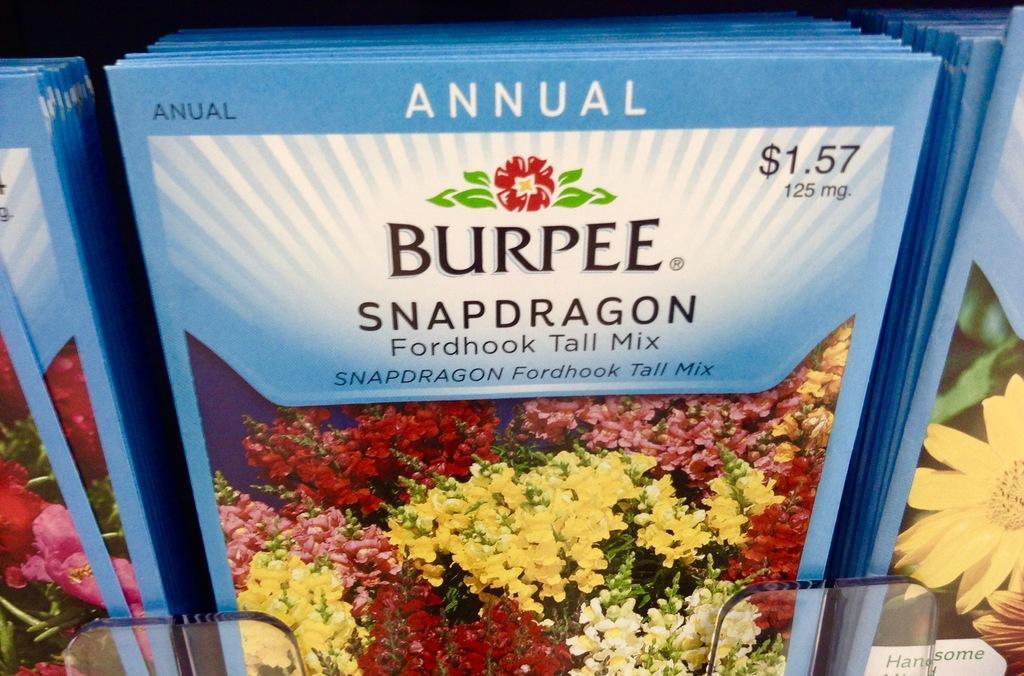Can you describe this image briefly? In this image in the center there are some packets, and on the packets there is some text and some flowers. 